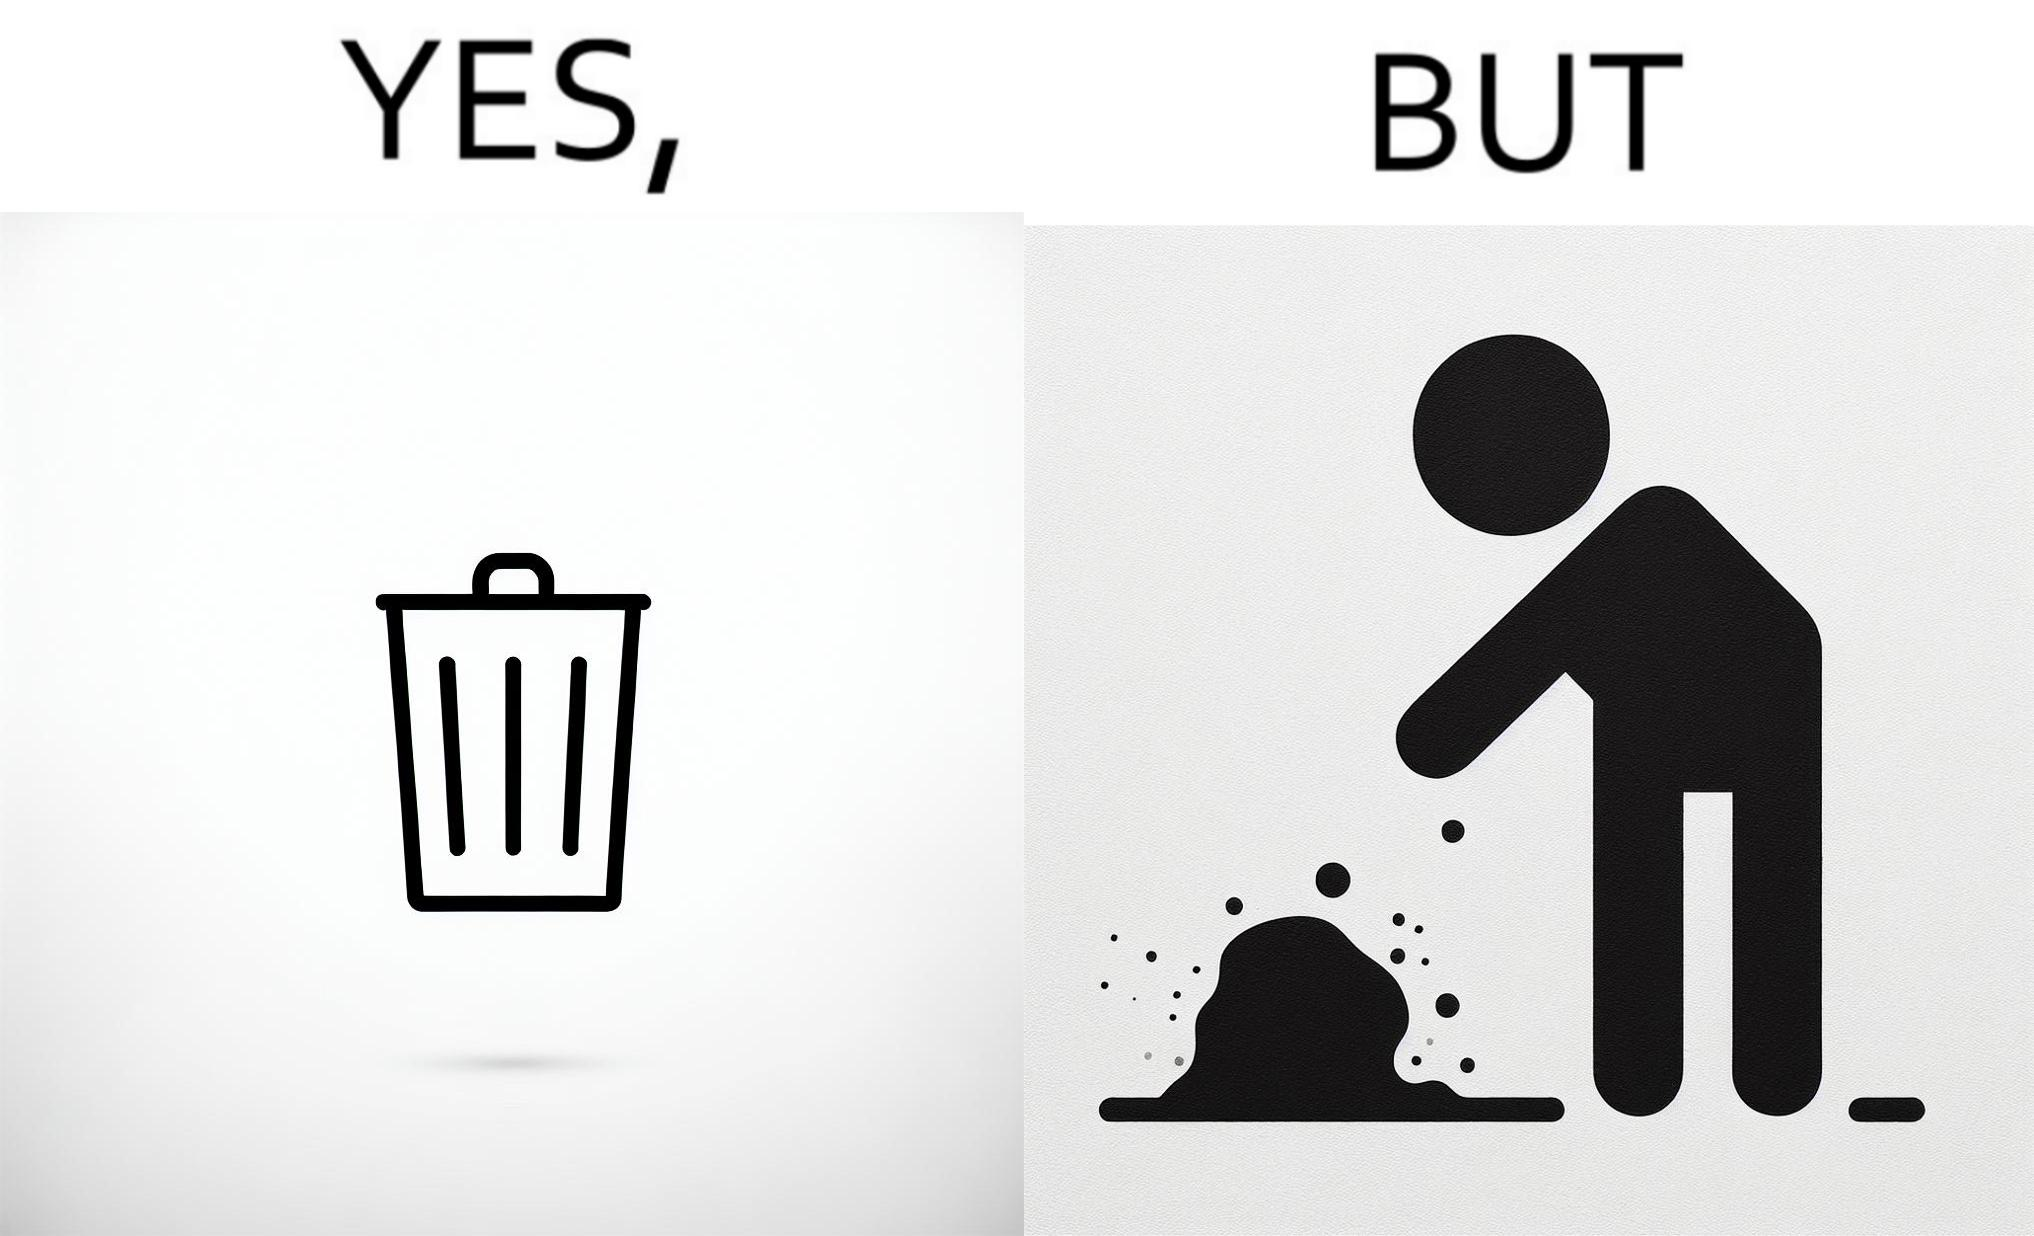Explain why this image is satirical. The images are ironic because even though garbage bins are provided for humans to dispose waste, by habit humans still choose to make surroundings dirty by disposing garbage improperly 